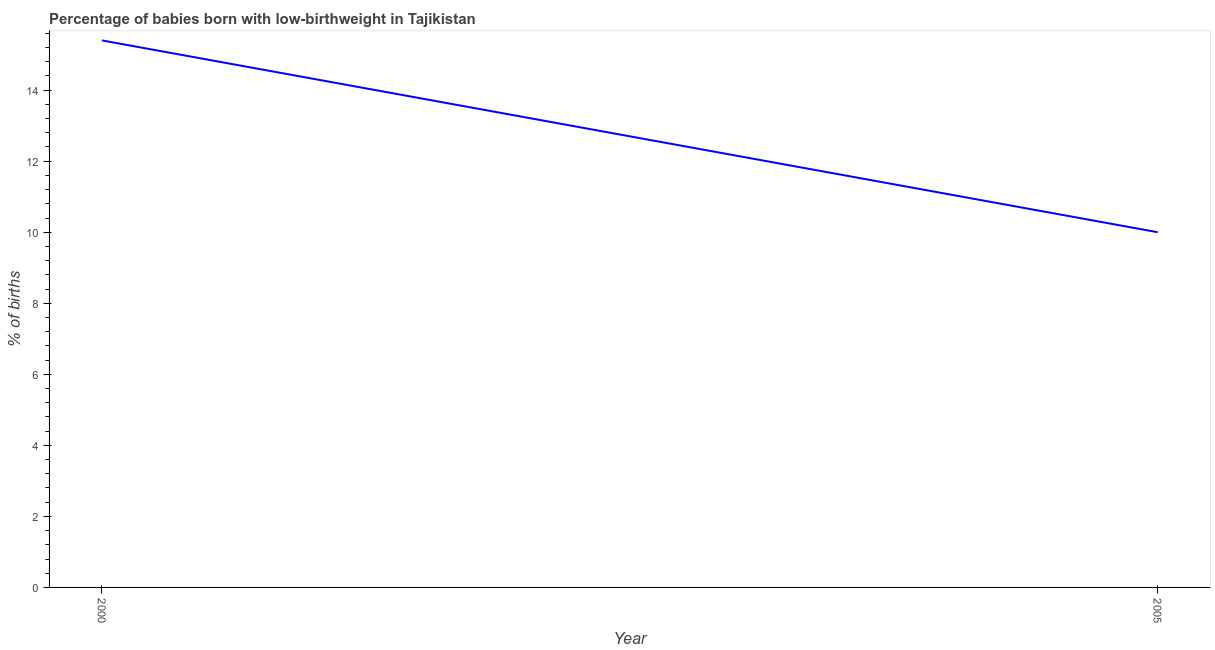Across all years, what is the maximum percentage of babies who were born with low-birthweight?
Your answer should be compact. 15.4. Across all years, what is the minimum percentage of babies who were born with low-birthweight?
Your answer should be very brief. 10. What is the sum of the percentage of babies who were born with low-birthweight?
Keep it short and to the point. 25.4. What is the average percentage of babies who were born with low-birthweight per year?
Provide a short and direct response. 12.7. In how many years, is the percentage of babies who were born with low-birthweight greater than 1.6 %?
Offer a terse response. 2. Do a majority of the years between 2000 and 2005 (inclusive) have percentage of babies who were born with low-birthweight greater than 12.4 %?
Provide a short and direct response. No. What is the ratio of the percentage of babies who were born with low-birthweight in 2000 to that in 2005?
Your answer should be very brief. 1.54. Is the percentage of babies who were born with low-birthweight in 2000 less than that in 2005?
Your answer should be very brief. No. In how many years, is the percentage of babies who were born with low-birthweight greater than the average percentage of babies who were born with low-birthweight taken over all years?
Keep it short and to the point. 1. Are the values on the major ticks of Y-axis written in scientific E-notation?
Give a very brief answer. No. Does the graph contain grids?
Ensure brevity in your answer.  No. What is the title of the graph?
Your answer should be very brief. Percentage of babies born with low-birthweight in Tajikistan. What is the label or title of the X-axis?
Your answer should be compact. Year. What is the label or title of the Y-axis?
Ensure brevity in your answer.  % of births. What is the difference between the % of births in 2000 and 2005?
Make the answer very short. 5.4. What is the ratio of the % of births in 2000 to that in 2005?
Your response must be concise. 1.54. 